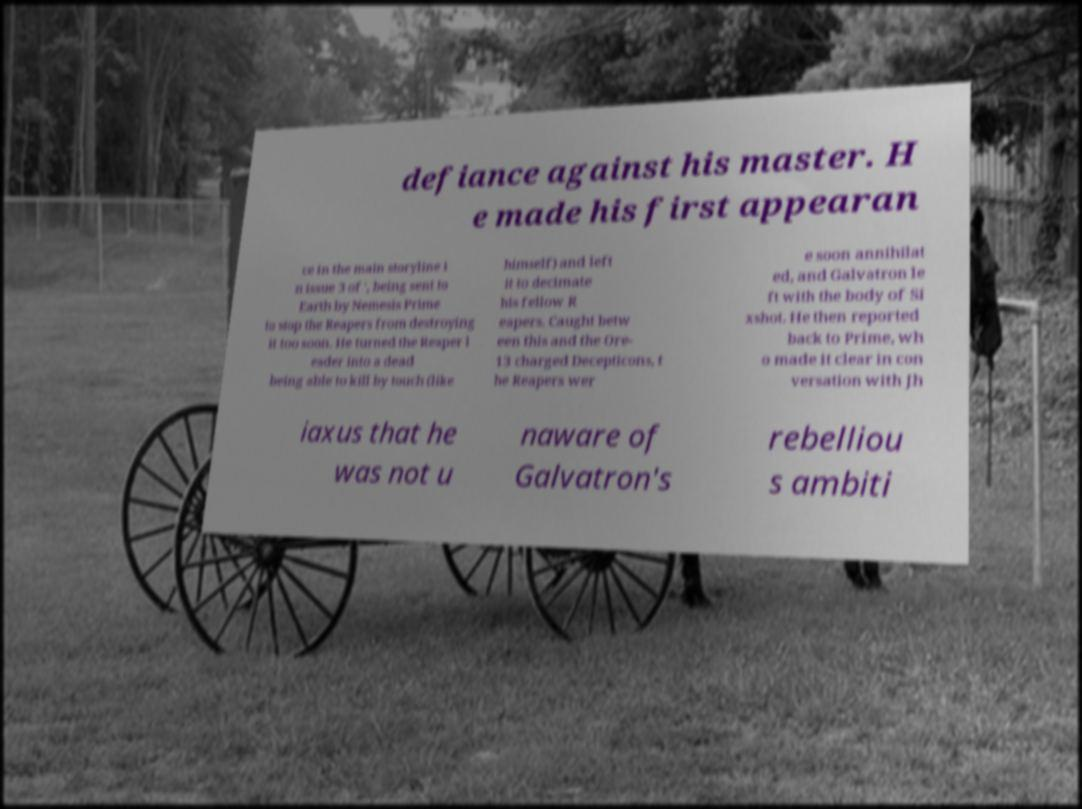Could you assist in decoding the text presented in this image and type it out clearly? defiance against his master. H e made his first appearan ce in the main storyline i n issue 3 of ', being sent to Earth by Nemesis Prime to stop the Reapers from destroying it too soon. He turned the Reaper l eader into a dead being able to kill by touch (like himself) and left it to decimate his fellow R eapers. Caught betw een this and the Ore- 13 charged Decepticons, t he Reapers wer e soon annihilat ed, and Galvatron le ft with the body of Si xshot. He then reported back to Prime, wh o made it clear in con versation with Jh iaxus that he was not u naware of Galvatron's rebelliou s ambiti 